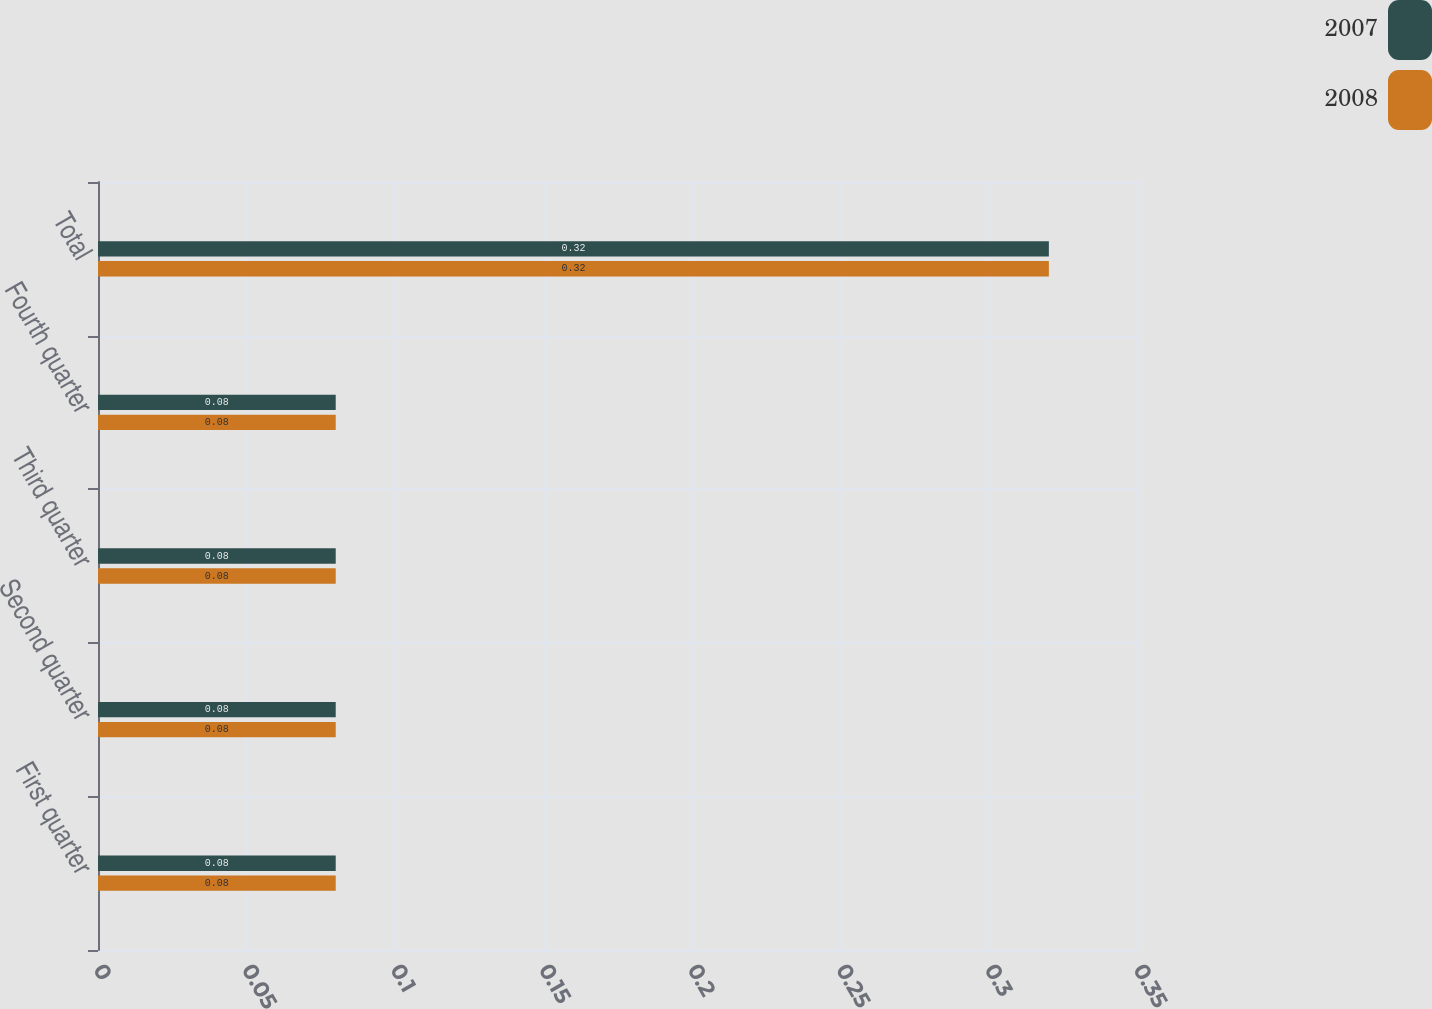Convert chart. <chart><loc_0><loc_0><loc_500><loc_500><stacked_bar_chart><ecel><fcel>First quarter<fcel>Second quarter<fcel>Third quarter<fcel>Fourth quarter<fcel>Total<nl><fcel>2007<fcel>0.08<fcel>0.08<fcel>0.08<fcel>0.08<fcel>0.32<nl><fcel>2008<fcel>0.08<fcel>0.08<fcel>0.08<fcel>0.08<fcel>0.32<nl></chart> 